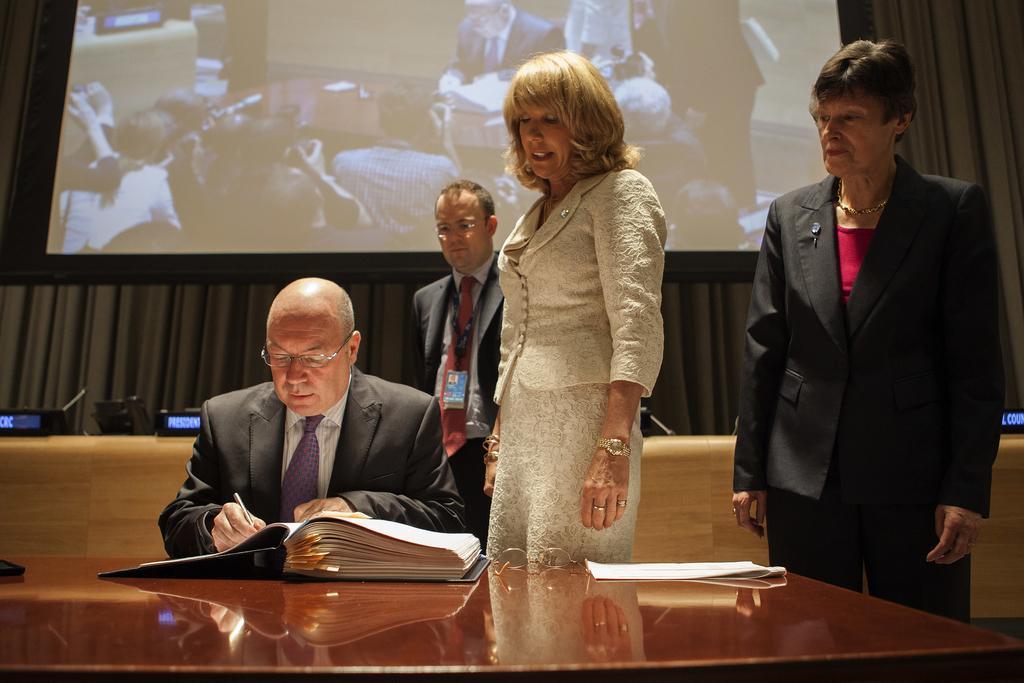In one or two sentences, can you explain what this image depicts? On the left side, there is a person in a suit, writing something in a book which is on a wooden table. On this table, there is a spectacle and a document. On the right side, there are two women. One of them is speaking. In the background, there is a person, a screen and a curtain. 